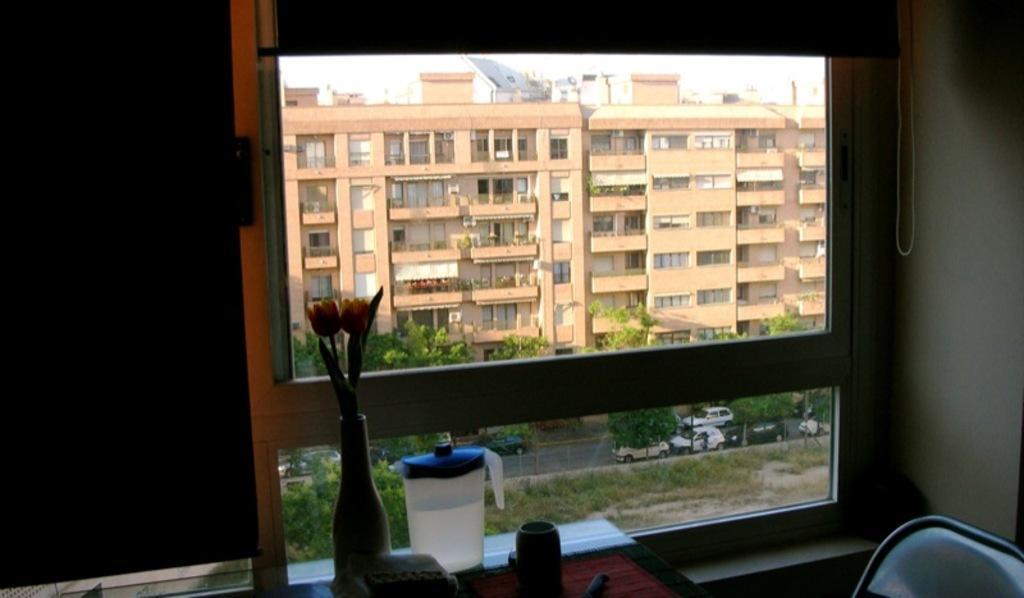Please provide a concise description of this image. In this image we can see some buildings, some poles, some vehicles on the road, some objects on the surface, some trees, bushes, plants and grass on the surface. There is one glass window, one flower pot with flowers near to the window, one wire, some objects are on the table, one mug with water on the table, one chair near to the table. 